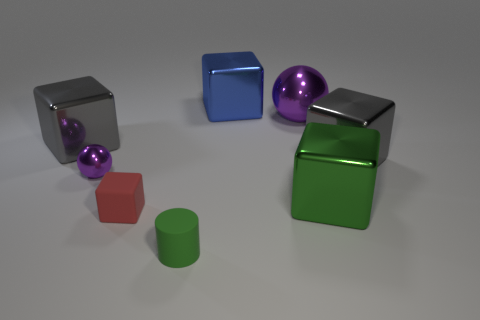How many other objects are the same material as the tiny green object?
Provide a succinct answer. 1. There is a metal cube on the left side of the sphere that is to the left of the purple metal thing that is right of the cylinder; what is its color?
Your answer should be very brief. Gray. What number of other objects are there of the same color as the large shiny sphere?
Your answer should be very brief. 1. Are there fewer small matte objects than red rubber things?
Keep it short and to the point. No. What is the color of the big shiny cube that is both to the left of the large purple object and on the right side of the tiny red matte block?
Your response must be concise. Blue. There is a large green thing that is the same shape as the red rubber thing; what material is it?
Provide a succinct answer. Metal. Are there any other things that have the same size as the green rubber thing?
Your answer should be very brief. Yes. Are there more green cubes than tiny metal cylinders?
Your answer should be compact. Yes. There is a thing that is in front of the green shiny object and behind the small green matte object; what is its size?
Provide a short and direct response. Small. There is a green metallic thing; what shape is it?
Provide a short and direct response. Cube. 